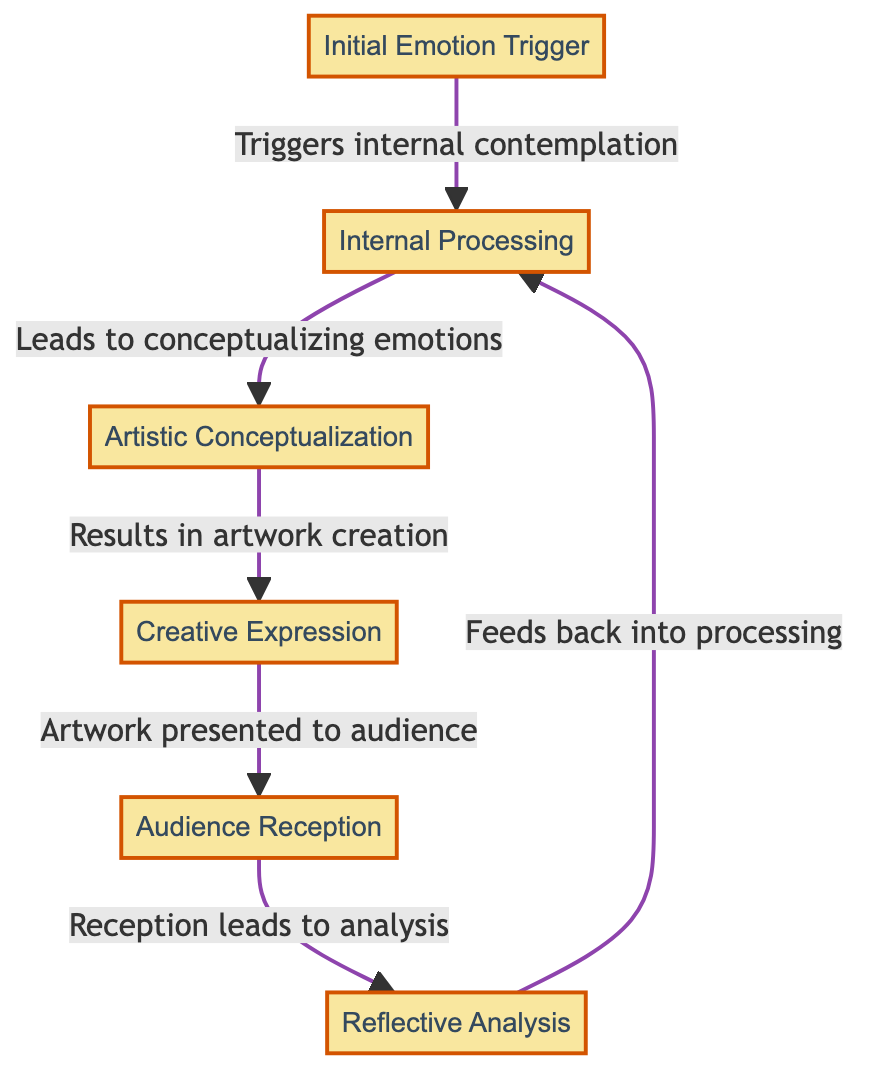What is the first node in the diagram? The first node is labeled "Initial Emotion Trigger," which is where the journey begins.
Answer: Initial Emotion Trigger How many nodes are in the flow chart? By counting each distinct entity shown in the diagram, there are a total of six nodes representing different stages in the emotional journey.
Answer: 6 What does the edge between nodes 2 and 3 indicate? The edge implies that "Internal Processing" leads to "Artistic Conceptualization," showing the flow from one phase to another.
Answer: Leads to conceptualizing emotions What is represented by the last node in the chart? The last node, "Reflective Analysis," represents the stage where the creator reflects on audience reception and their overall emotional journey.
Answer: Reflective Analysis Which node responds to audience feedback? The node that responds to audience feedback is "Reflective Analysis," which involves analyzing the reception of the artwork created.
Answer: Reflective Analysis What happens after "Audience Reception"? After "Audience Reception," the process leads to "Reflective Analysis," where the audience's reactions are analyzed and reflected upon.
Answer: Reflective Analysis What emotion triggers the flow of the diagram? The emotion that triggers the flow is represented by the first node, which is "Initial Emotion Trigger," encompassing significant life events.
Answer: Initial Emotion Trigger What phase occurs immediately after "Creative Expression"? The phase that occurs immediately after "Creative Expression" is "Audience Reception," where the artwork is presented and received by the audience.
Answer: Audience Reception How does "Reflective Analysis" influence "Internal Processing"? "Reflective Analysis" influences "Internal Processing" by feeding back into it, indicating that reflections may inform future experiences and creations.
Answer: Feeds back into processing 